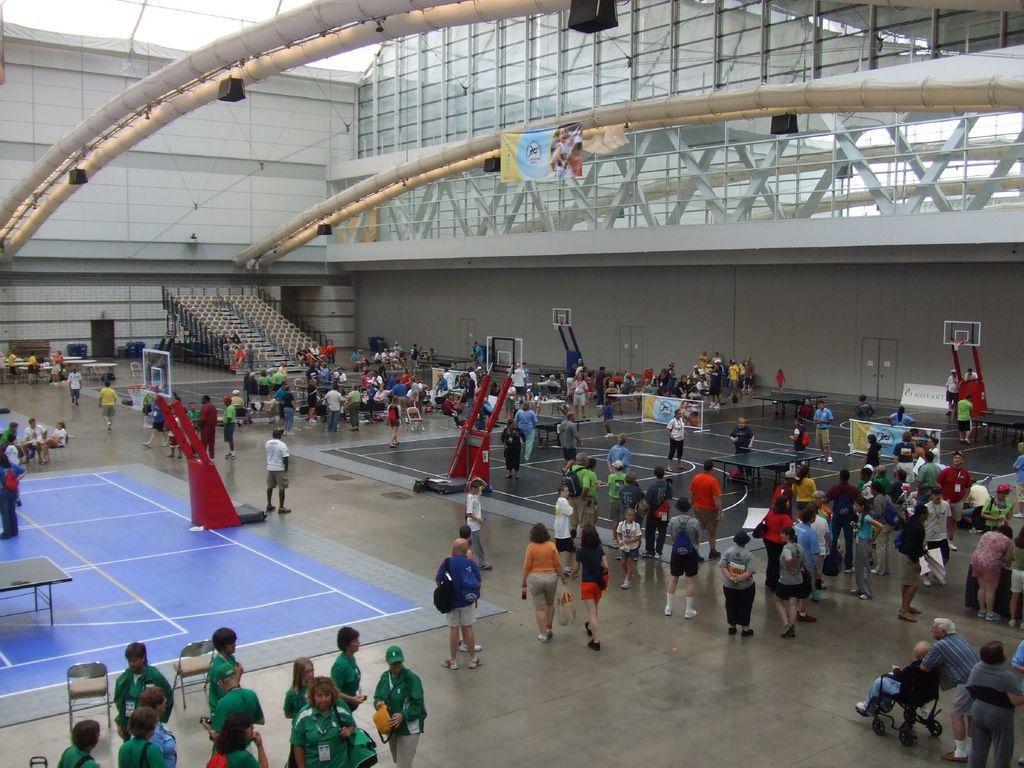Please provide a concise description of this image. In this picture we can see two batman ten carts, few people are playing, around we can see some people are standing and watching and we can see some stars cases. 